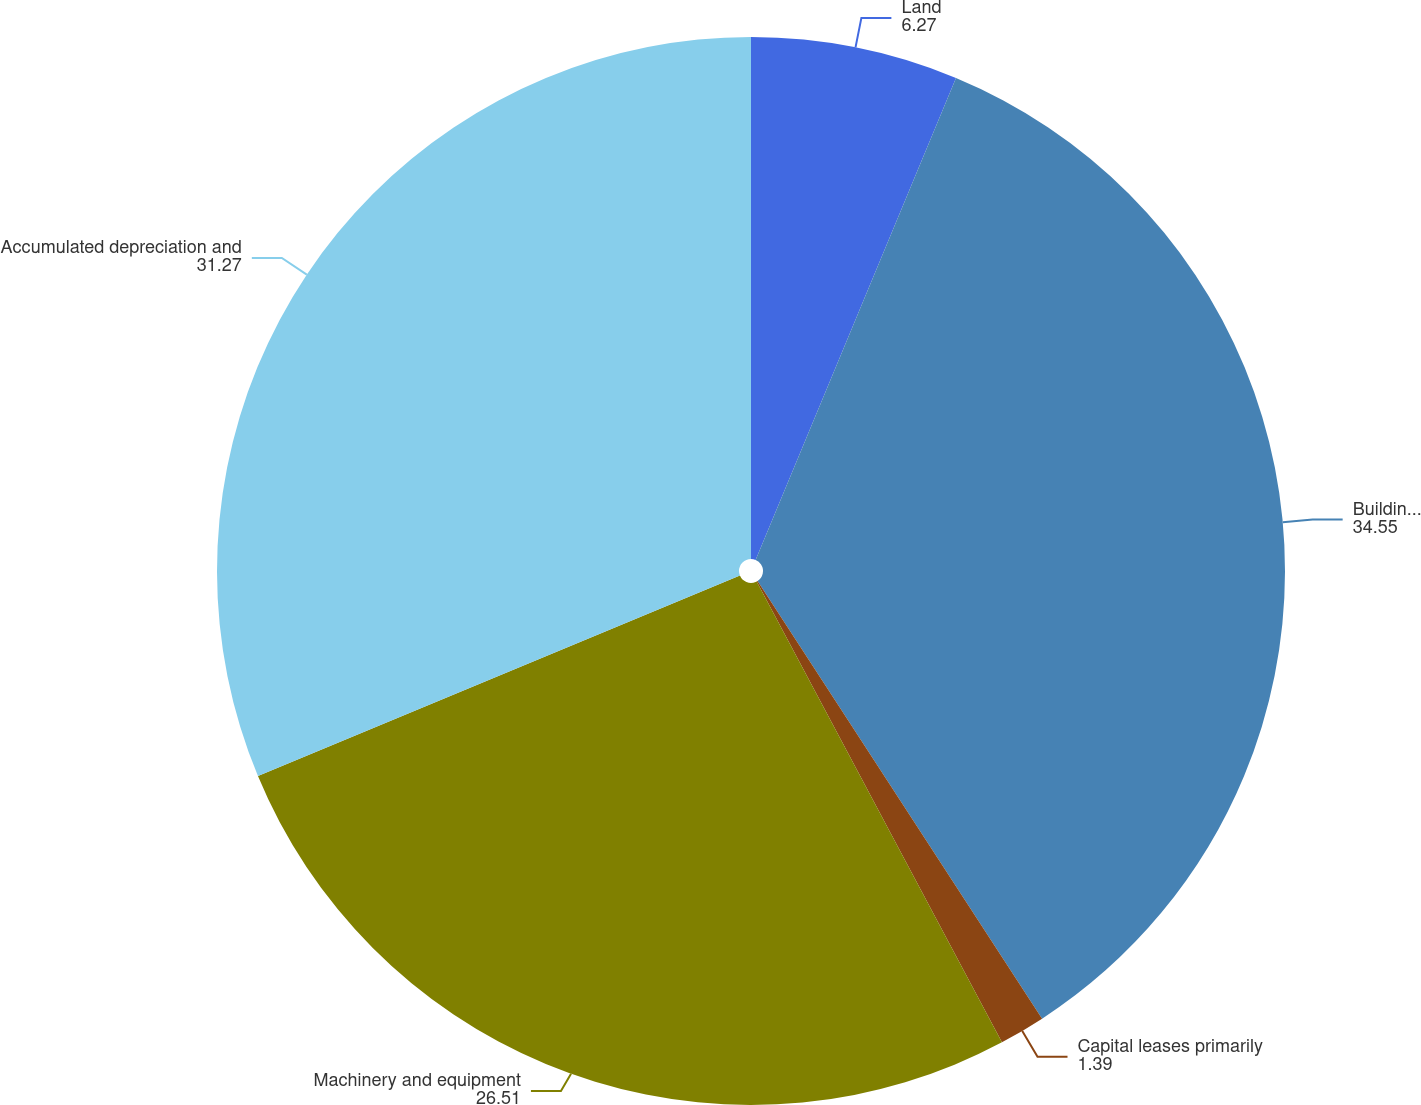<chart> <loc_0><loc_0><loc_500><loc_500><pie_chart><fcel>Land<fcel>Buildings and improvements<fcel>Capital leases primarily<fcel>Machinery and equipment<fcel>Accumulated depreciation and<nl><fcel>6.27%<fcel>34.55%<fcel>1.39%<fcel>26.51%<fcel>31.27%<nl></chart> 